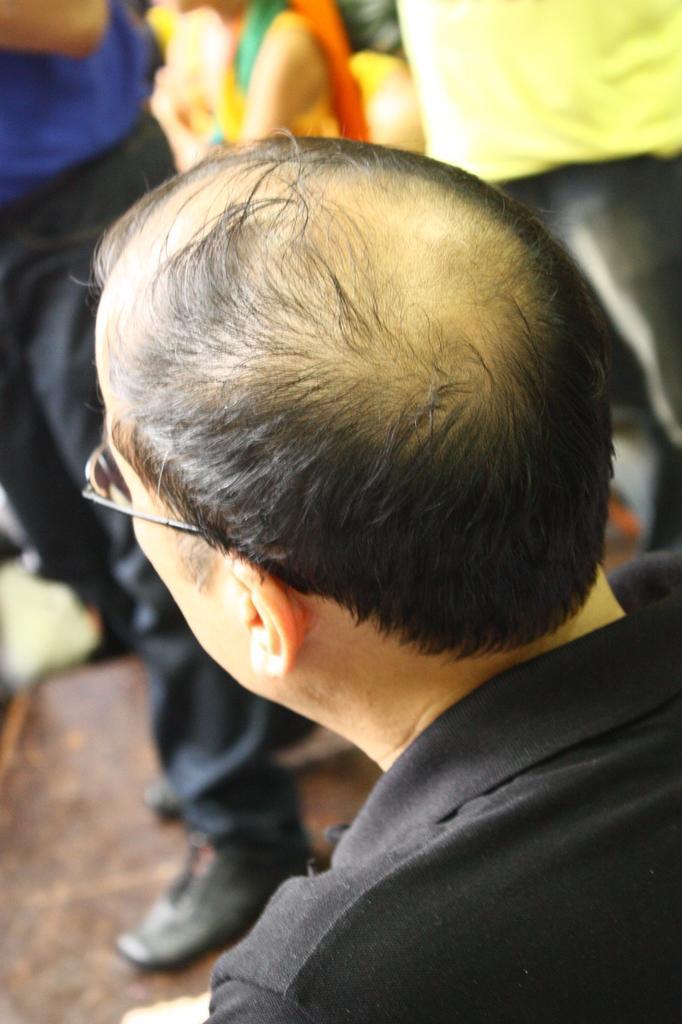How would you summarize this image in a sentence or two? In the foreground of the picture I can see a man wearing a black color T-shirt and I can see the spectacles on his eyes. In the background, I can see a few persons, though their faces are not visible. 